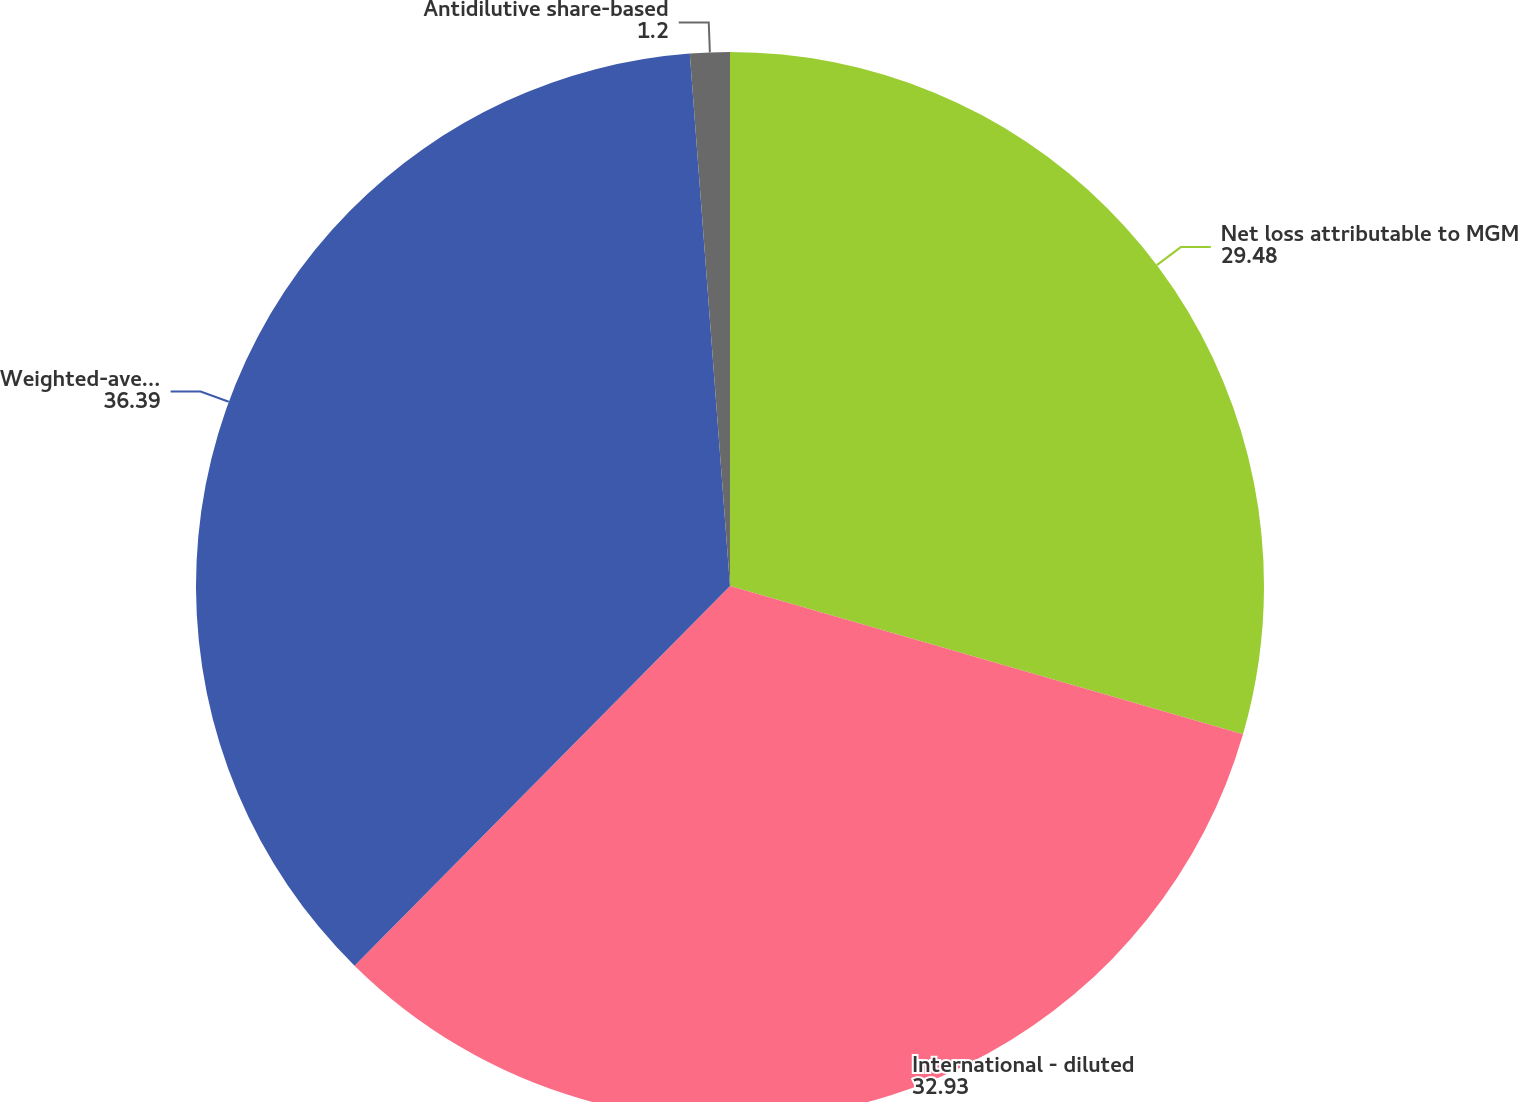Convert chart to OTSL. <chart><loc_0><loc_0><loc_500><loc_500><pie_chart><fcel>Net loss attributable to MGM<fcel>International - diluted<fcel>Weighted-average common shares<fcel>Antidilutive share-based<nl><fcel>29.48%<fcel>32.93%<fcel>36.39%<fcel>1.2%<nl></chart> 